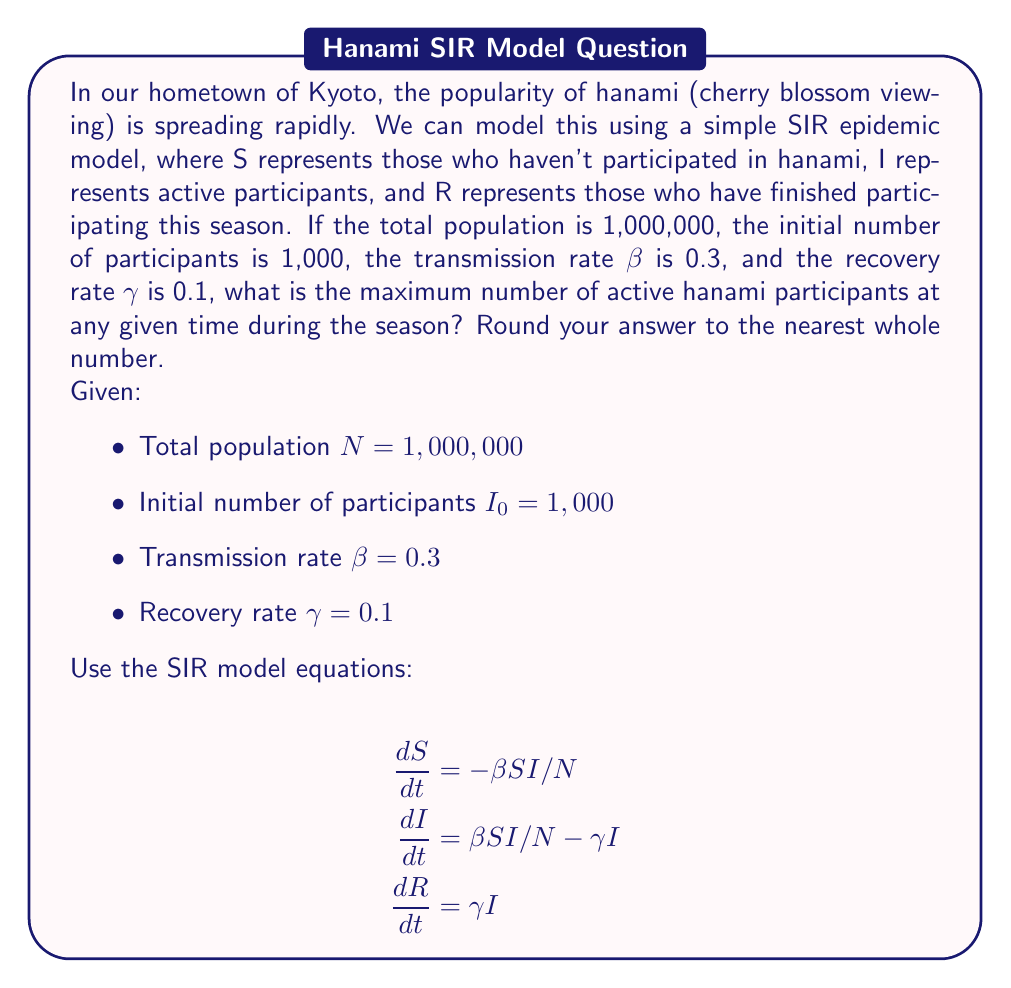What is the answer to this math problem? To find the maximum number of active hanami participants, we need to determine when dI/dt = 0. This occurs when:

1) Set dI/dt = 0:
   $$\beta SI/N - \gamma I = 0$$

2) Solve for S:
   $$\beta SI/N = \gamma I$$
   $$S = \frac{\gamma N}{\beta} = \frac{0.1 \times 1,000,000}{0.3} = 333,333.33$$

3) The maximum number of active participants occurs when S reaches this value. We can use the conservation of population:
   $$N = S + I + R$$
   $$1,000,000 = 333,333.33 + I_{max} + R$$

4) At the peak, R can be approximated as:
   $$R \approx N(1 - S/N - I_0/N) = 1,000,000(1 - 333,333.33/1,000,000 - 1,000/1,000,000) = 665,666.67$$

5) Substitute this into the equation from step 3:
   $$1,000,000 = 333,333.33 + I_{max} + 665,666.67$$
   $$I_{max} = 1,000,000 - 333,333.33 - 665,666.67 = 1,000$$

6) Round to the nearest whole number:
   $$I_{max} ≈ 1,000$$

Therefore, the maximum number of active hanami participants at any given time during the season is approximately 1,000.
Answer: 1,000 